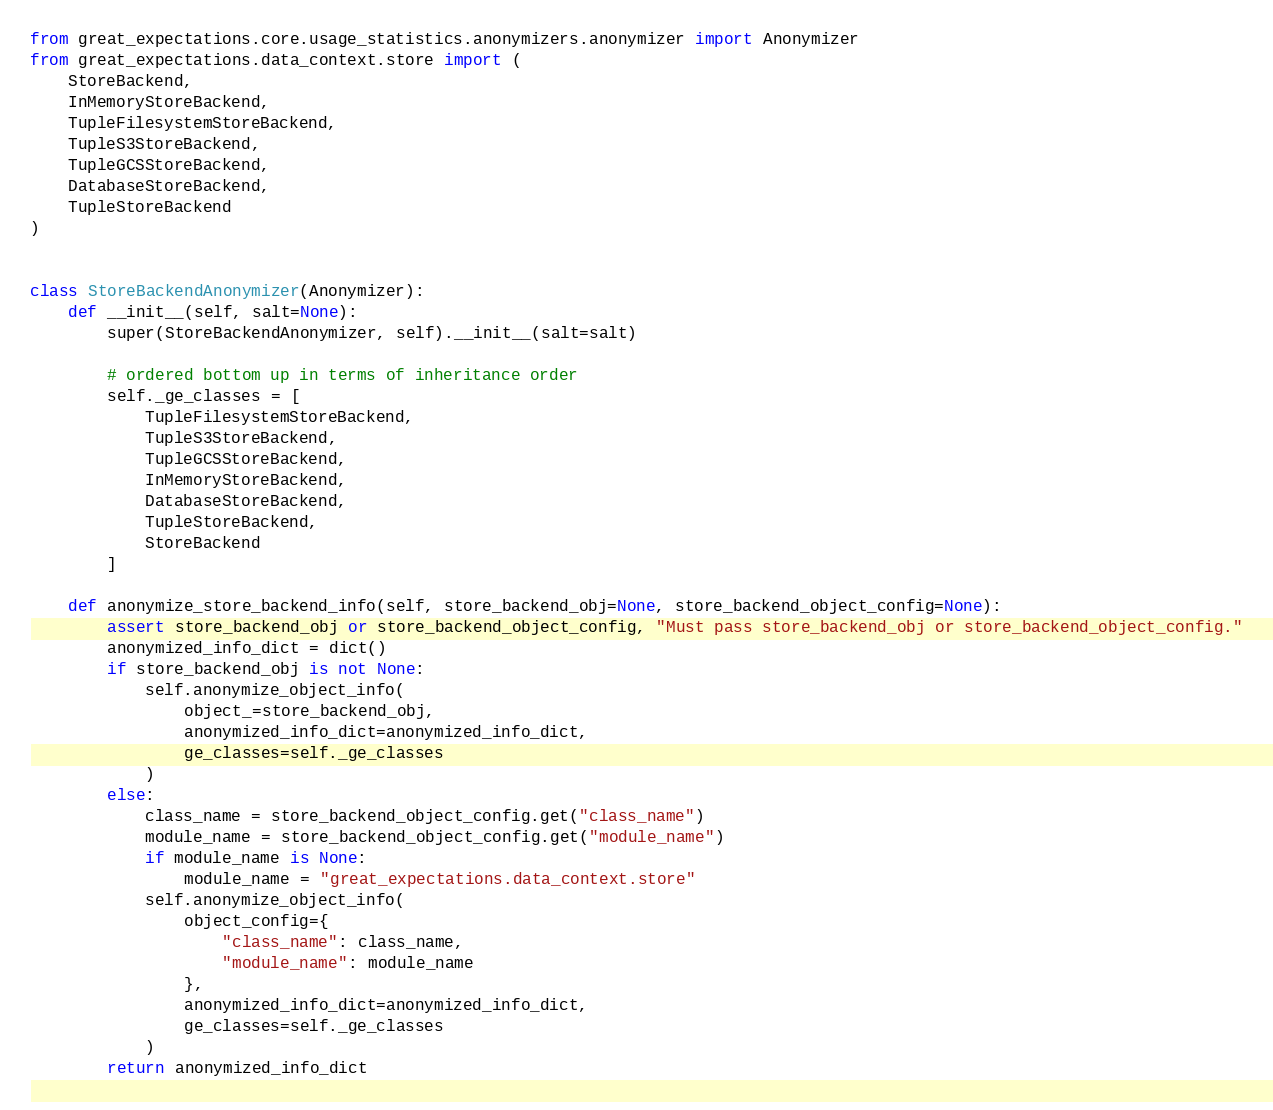Convert code to text. <code><loc_0><loc_0><loc_500><loc_500><_Python_>from great_expectations.core.usage_statistics.anonymizers.anonymizer import Anonymizer
from great_expectations.data_context.store import (
    StoreBackend,
    InMemoryStoreBackend,
    TupleFilesystemStoreBackend,
    TupleS3StoreBackend,
    TupleGCSStoreBackend,
    DatabaseStoreBackend,
    TupleStoreBackend
)


class StoreBackendAnonymizer(Anonymizer):
    def __init__(self, salt=None):
        super(StoreBackendAnonymizer, self).__init__(salt=salt)

        # ordered bottom up in terms of inheritance order
        self._ge_classes = [
            TupleFilesystemStoreBackend,
            TupleS3StoreBackend,
            TupleGCSStoreBackend,
            InMemoryStoreBackend,
            DatabaseStoreBackend,
            TupleStoreBackend,
            StoreBackend
        ]

    def anonymize_store_backend_info(self, store_backend_obj=None, store_backend_object_config=None):
        assert store_backend_obj or store_backend_object_config, "Must pass store_backend_obj or store_backend_object_config."
        anonymized_info_dict = dict()
        if store_backend_obj is not None:
            self.anonymize_object_info(
                object_=store_backend_obj,
                anonymized_info_dict=anonymized_info_dict,
                ge_classes=self._ge_classes
            )
        else:
            class_name = store_backend_object_config.get("class_name")
            module_name = store_backend_object_config.get("module_name")
            if module_name is None:
                module_name = "great_expectations.data_context.store"
            self.anonymize_object_info(
                object_config={
                    "class_name": class_name,
                    "module_name": module_name
                },
                anonymized_info_dict=anonymized_info_dict,
                ge_classes=self._ge_classes
            )
        return anonymized_info_dict
</code> 